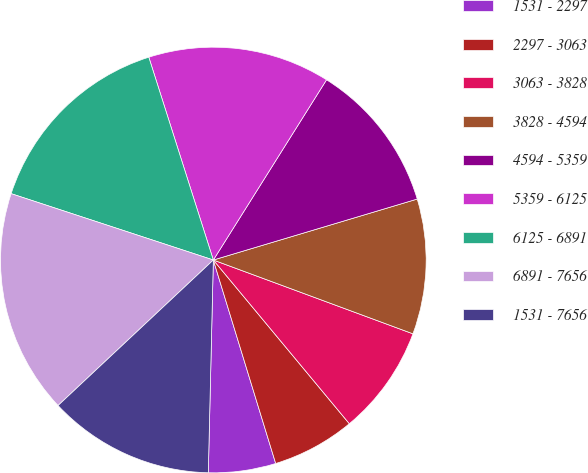<chart> <loc_0><loc_0><loc_500><loc_500><pie_chart><fcel>1531 - 2297<fcel>2297 - 3063<fcel>3063 - 3828<fcel>3828 - 4594<fcel>4594 - 5359<fcel>5359 - 6125<fcel>6125 - 6891<fcel>6891 - 7656<fcel>1531 - 7656<nl><fcel>5.11%<fcel>6.3%<fcel>8.33%<fcel>10.26%<fcel>11.45%<fcel>13.83%<fcel>15.05%<fcel>17.03%<fcel>12.64%<nl></chart> 